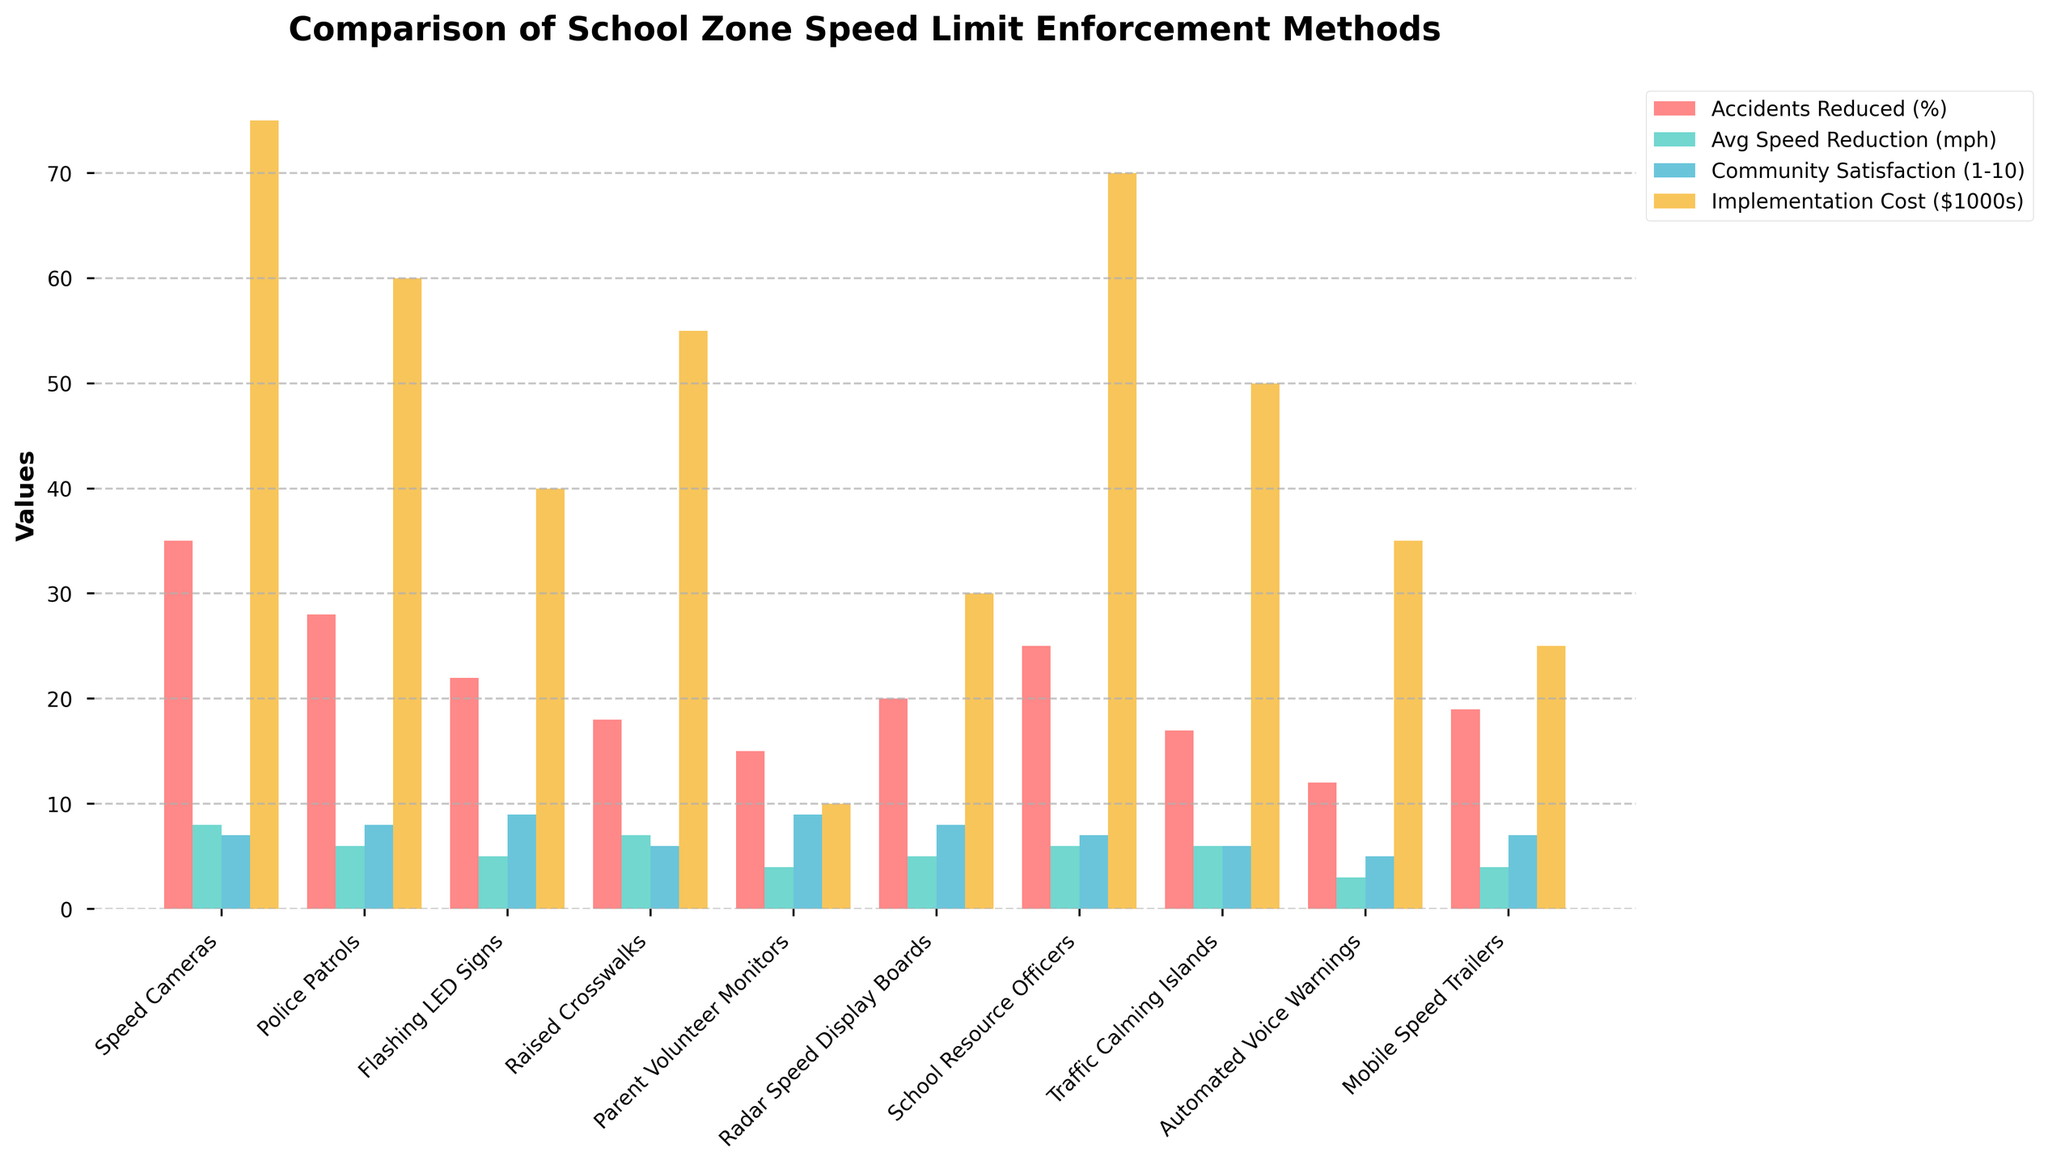Which enforcement method has the highest percentage of accidents reduced? The red bars represent accidents reduced. The tallest red bar corresponds to Speed Cameras.
Answer: Speed Cameras Which enforcement method has the lowest implementation cost? The yellow bars represent implementation costs. The shortest yellow bar corresponds to Parent Volunteer Monitors.
Answer: Parent Volunteer Monitors Comparing Police Patrols and Speed Cameras, which method has a higher community satisfaction rating? The blue bars represent community satisfaction. The slightly taller blue bar for Police Patrols indicates higher community satisfaction.
Answer: Police Patrols What is the average speed reduction achieved by Raised Crosswalks and School Resource Officers? The cyan bars show average speed reduction. Raised Crosswalks and School Resource Officers have bars at 7 mph and 6 mph respectively, leading to an average of (7+6)/2.
Answer: 6.5 mph Which enforcement method results in the highest community satisfaction? The blue bars represent community satisfaction. The highest blue bar corresponds to Flashing LED Signs and Parent Volunteer Monitors, both at 9.
Answer: Flashing LED Signs and Parent Volunteer Monitors How much more does it cost to implement Speed Cameras compared to Mobile Speed Trailers? Comparing the yellow bars of Speed Cameras (75) and Mobile Speed Trailers (25), the difference is 75 - 25.
Answer: 50 Which two enforcement methods achieve the same average speed reduction? The cyan bars indicate average speed reduction. Both Flashing LED Signs and Radar Speed Display Boards have bars at 5 mph.
Answer: Flashing LED Signs and Radar Speed Display Boards If you combine the community satisfaction scores of Radar Speed Display Boards and Automated Voice Warnings, what is the total? The blue bars show community satisfaction. Radar Speed Display Boards have a score of 8 and Automated Voice Warnings have a score of 5. Adding these gives 8 + 5.
Answer: 13 Which enforcement method has the second highest average speed reduction? The cyan bars show average speed reduction. The second tallest cyan bar corresponds to Raised Crosswalks, just below Speed Cameras.
Answer: Raised Crosswalks Are there any enforcement methods with the same implementation cost? The yellow bars need to be compared. Raised Crosswalks and Traffic Calming Islands both have a cost of 50.
Answer: Raised Crosswalks and Traffic Calming Islands 